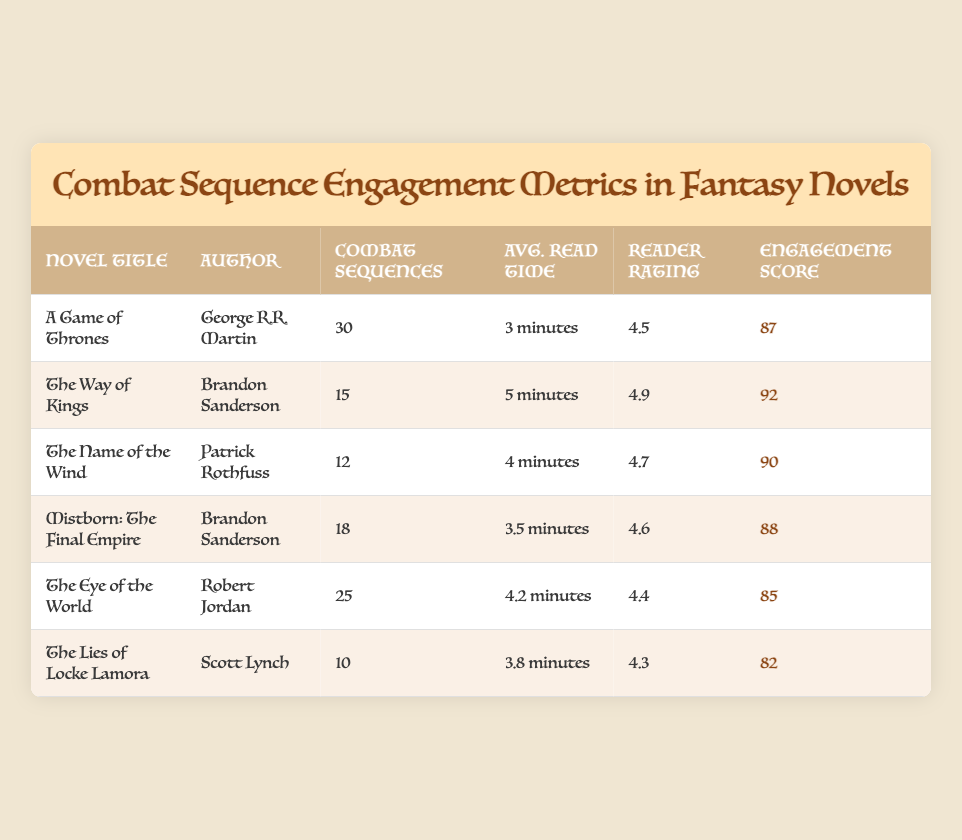What is the novel with the highest reader rating? The novel with the highest reader rating is "The Way of Kings" with a rating of 4.9. This information can be found in the "Reader Rating" column by comparing the values for each novel.
Answer: The Way of Kings How many combat sequences are described in "The Name of the Wind"? "The Name of the Wind" has a total of 12 combat sequences, as indicated in the "Combat Sequences" column.
Answer: 12 What is the average read time for combat sequences in "A Game of Thrones"? The average read time for combat sequences in "A Game of Thrones" is 3 minutes, which can be directly referenced from the "Avg. Read Time" column corresponding to this novel.
Answer: 3 minutes Which author has the most number of combat sequences across their novels? Brandon Sanderson has the most combat sequences when you add "The Way of Kings" (15) and "Mistborn: The Final Empire" (18), which totals to 33 sequences. By summing the combat sequence counts associated with each novel by this author, it's clear he leads.
Answer: Brandon Sanderson Is the engagement score for "The Lies of Locke Lamora" greater than 85? The engagement score for "The Lies of Locke Lamora" is 82, which is not greater than 85. This fact can be verified directly from the "Engagement Score" column for the novel.
Answer: No What is the difference in engagement scores between "The Way of Kings" and "The Eye of the World"? The engagement score for "The Way of Kings" is 92, and for "The Eye of the World" it is 85. The difference is calculated as 92 - 85 = 7, indicating how much higher the score for "The Way of Kings" is.
Answer: 7 Which novel has the lowest engagement score? The novel with the lowest engagement score is "The Lies of Locke Lamora" with a score of 82, which can be found by comparing the values in the "Engagement Score" column for each novel.
Answer: The Lies of Locke Lamora What is the average read time per combat sequence across all novels listed? To find the average read time across all novels, convert the read times into a uniform format. The total read times (in minutes) are 3 + 5 + 4 + 3.5 + 4.2 + 3.8 = 23.5 minutes, and there are 6 novels. Hence, the average read time is 23.5 / 6 = 3.92 minutes, rounding to approximately 3.9 minutes.
Answer: 3.9 minutes What is the total count of combat sequences across all novels listed? To find the total count of combat sequences, we sum the individual counts from the "Combat Sequences" column: 30 + 15 + 12 + 18 + 25 + 10 = 110. Therefore, the total is 110 combat sequences across all the novels.
Answer: 110 